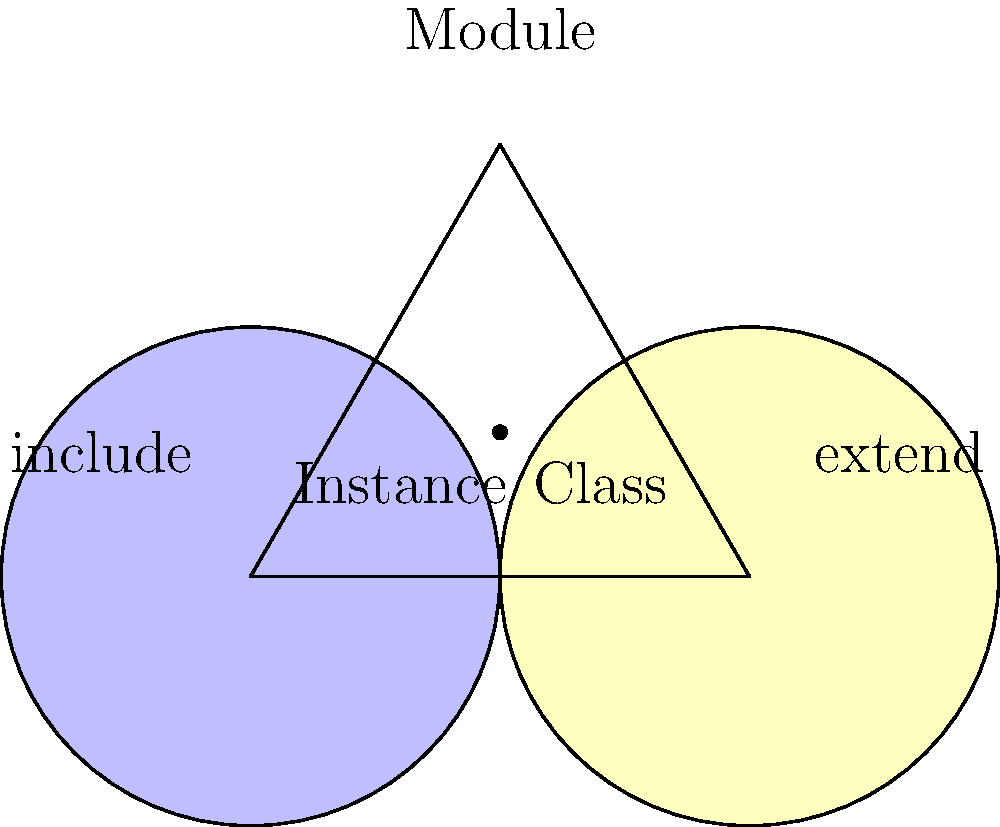Based on the Venn diagram representing Ruby's module system, which statement correctly describes the relationship between `include` and `extend` when used with modules? To understand the relationship between `include` and `extend` in Ruby modules, let's break down the Venn diagram:

1. The large triangle represents a Ruby module.
2. The left circle (blue) represents the `include` method.
3. The right circle (yellow) represents the `extend` method.
4. The overlapping region represents shared characteristics.
5. "Instance" is labeled in the `include` circle.
6. "Class" is labeled in the `extend` circle.

Now, let's analyze the implications:

1. `include` adds module methods as instance methods to the including class. This is why "Instance" is in the `include` circle.
2. `extend` adds module methods as class methods to the extending class. This is why "Class" is in the `extend` circle.
3. The overlapping region suggests that both `include` and `extend` can be used on the same module, but with different effects.
4. The module itself (the triangle) encompasses both `include` and `extend`, indicating that a module can be used with either method.

The key difference is that `include` affects instance methods, while `extend` affects class methods. This is visually represented by their separate circles within the module triangle.
Answer: `include` adds instance methods, `extend` adds class methods 